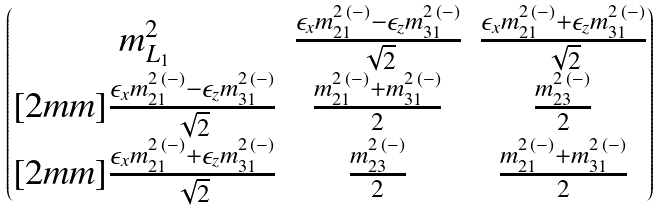<formula> <loc_0><loc_0><loc_500><loc_500>\begin{pmatrix} m _ { L _ { 1 } } ^ { 2 } & \frac { \epsilon _ { x } m ^ { 2 \, ( - ) } _ { 2 1 } - \epsilon _ { z } m ^ { 2 \, ( - ) } _ { 3 1 } } { \sqrt { 2 } } & \frac { \epsilon _ { x } m ^ { 2 \, ( - ) } _ { 2 1 } + \epsilon _ { z } m ^ { 2 \, ( - ) } _ { 3 1 } } { \sqrt { 2 } } \\ [ 2 m m ] \frac { \epsilon _ { x } m ^ { 2 \, ( - ) } _ { 2 1 } - \epsilon _ { z } m ^ { 2 \, ( - ) } _ { 3 1 } } { \sqrt { 2 } } & \frac { m ^ { 2 \, ( - ) } _ { 2 1 } + m ^ { 2 \, ( - ) } _ { 3 1 } } { 2 } & \frac { m ^ { 2 \, ( - ) } _ { 2 3 } } { 2 } \\ [ 2 m m ] \frac { \epsilon _ { x } m ^ { 2 \, ( - ) } _ { 2 1 } + \epsilon _ { z } m ^ { 2 \, ( - ) } _ { 3 1 } } { \sqrt { 2 } } & \frac { m ^ { 2 \, ( - ) } _ { 2 3 } } { 2 } & \frac { m ^ { 2 \, ( - ) } _ { 2 1 } + m ^ { 2 \, ( - ) } _ { 3 1 } } { 2 } \end{pmatrix}</formula> 